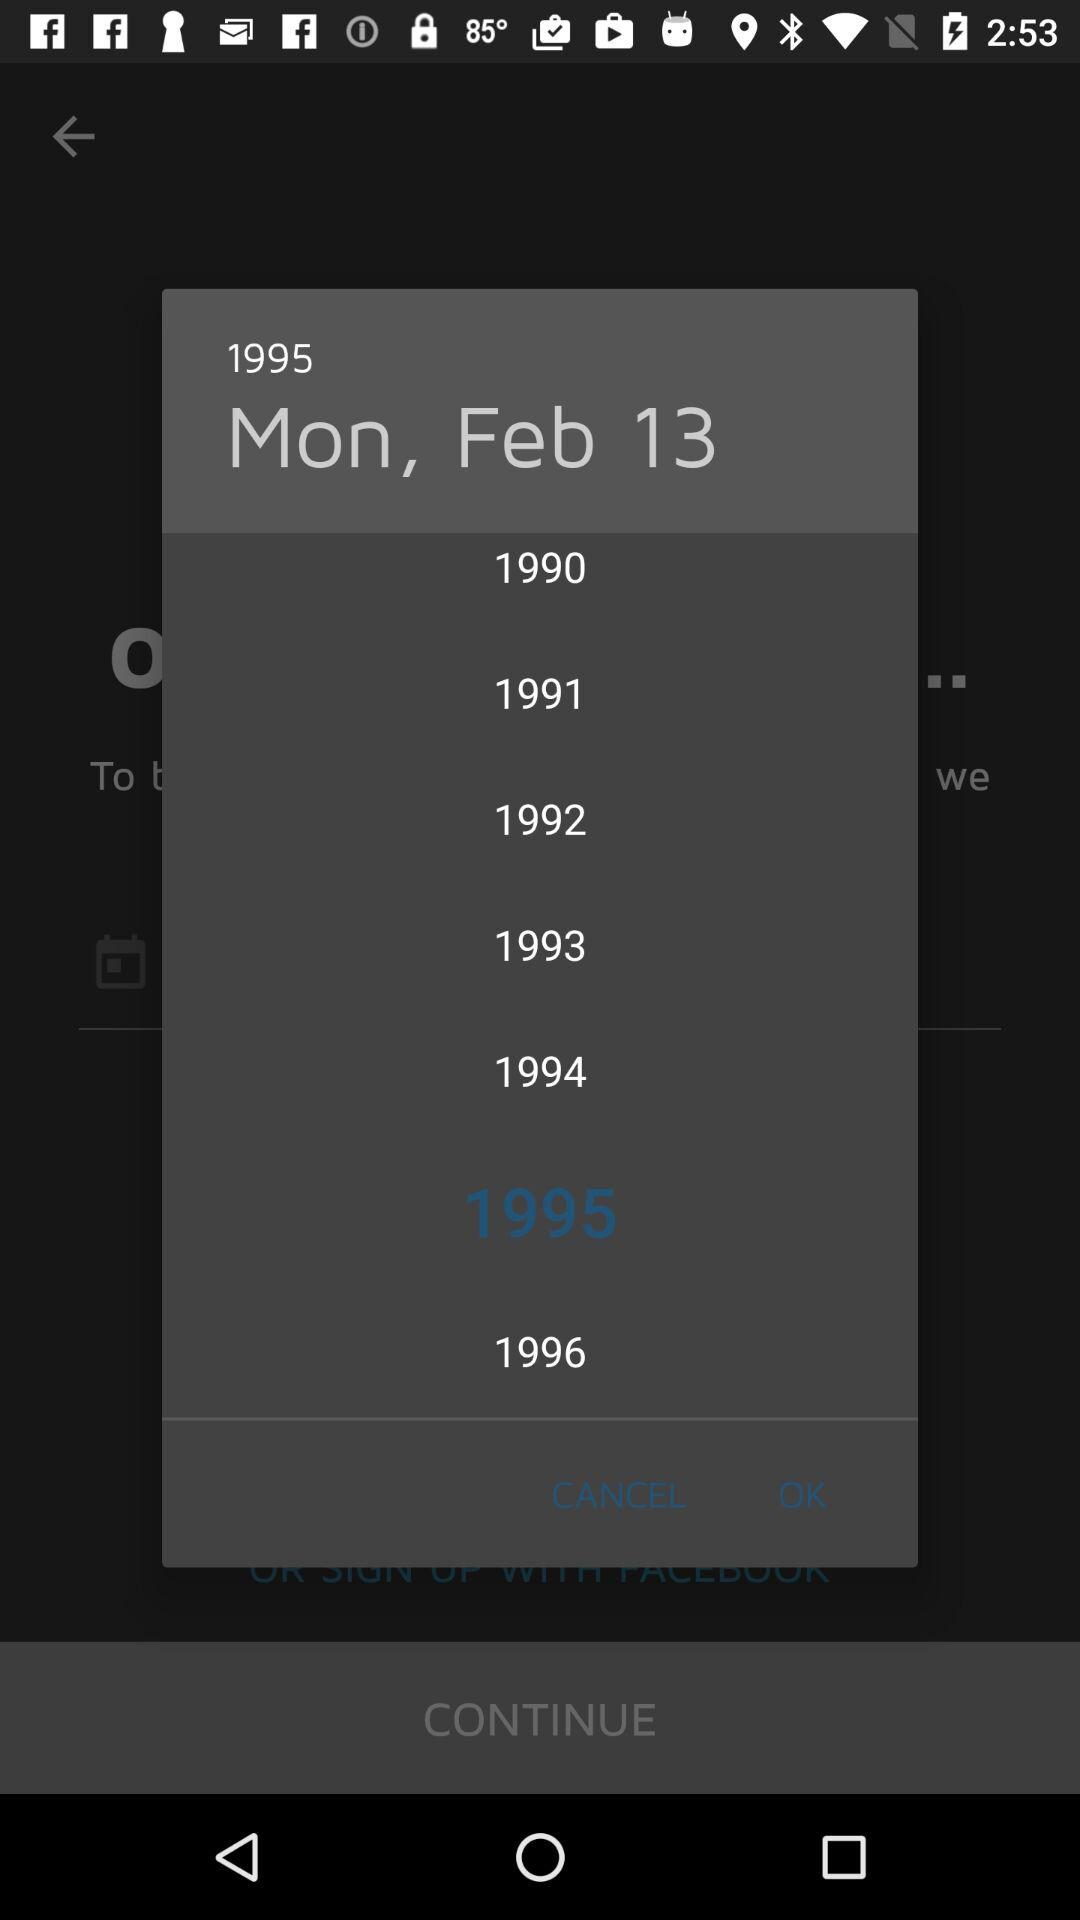What is the selected date? The selected date is Monday, February 13, 1995. 